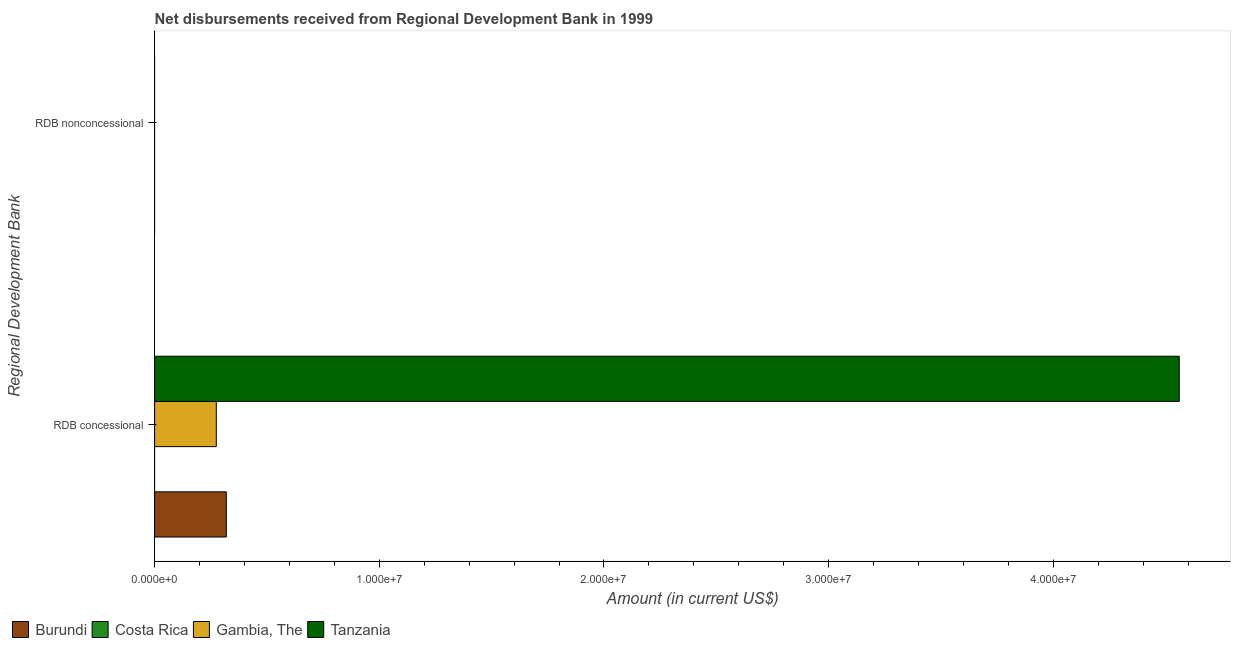How many different coloured bars are there?
Offer a terse response. 3. What is the label of the 2nd group of bars from the top?
Give a very brief answer. RDB concessional. What is the net concessional disbursements from rdb in Gambia, The?
Give a very brief answer. 2.75e+06. Across all countries, what is the maximum net concessional disbursements from rdb?
Give a very brief answer. 4.56e+07. Across all countries, what is the minimum net concessional disbursements from rdb?
Your answer should be compact. 0. In which country was the net concessional disbursements from rdb maximum?
Your answer should be compact. Tanzania. What is the total net non concessional disbursements from rdb in the graph?
Ensure brevity in your answer.  0. What is the difference between the net concessional disbursements from rdb in Gambia, The and that in Burundi?
Provide a succinct answer. -4.45e+05. What is the difference between the net concessional disbursements from rdb in Burundi and the net non concessional disbursements from rdb in Gambia, The?
Ensure brevity in your answer.  3.19e+06. What is the ratio of the net concessional disbursements from rdb in Tanzania to that in Burundi?
Give a very brief answer. 14.29. How many bars are there?
Provide a short and direct response. 3. How many countries are there in the graph?
Give a very brief answer. 4. What is the title of the graph?
Make the answer very short. Net disbursements received from Regional Development Bank in 1999. Does "Egypt, Arab Rep." appear as one of the legend labels in the graph?
Your answer should be very brief. No. What is the label or title of the Y-axis?
Keep it short and to the point. Regional Development Bank. What is the Amount (in current US$) in Burundi in RDB concessional?
Your answer should be very brief. 3.19e+06. What is the Amount (in current US$) in Costa Rica in RDB concessional?
Your response must be concise. 0. What is the Amount (in current US$) of Gambia, The in RDB concessional?
Provide a short and direct response. 2.75e+06. What is the Amount (in current US$) of Tanzania in RDB concessional?
Provide a short and direct response. 4.56e+07. What is the Amount (in current US$) of Tanzania in RDB nonconcessional?
Your response must be concise. 0. Across all Regional Development Bank, what is the maximum Amount (in current US$) of Burundi?
Give a very brief answer. 3.19e+06. Across all Regional Development Bank, what is the maximum Amount (in current US$) of Gambia, The?
Make the answer very short. 2.75e+06. Across all Regional Development Bank, what is the maximum Amount (in current US$) in Tanzania?
Your answer should be very brief. 4.56e+07. Across all Regional Development Bank, what is the minimum Amount (in current US$) of Burundi?
Offer a terse response. 0. Across all Regional Development Bank, what is the minimum Amount (in current US$) of Gambia, The?
Your answer should be compact. 0. Across all Regional Development Bank, what is the minimum Amount (in current US$) in Tanzania?
Provide a succinct answer. 0. What is the total Amount (in current US$) in Burundi in the graph?
Give a very brief answer. 3.19e+06. What is the total Amount (in current US$) of Gambia, The in the graph?
Provide a succinct answer. 2.75e+06. What is the total Amount (in current US$) of Tanzania in the graph?
Give a very brief answer. 4.56e+07. What is the average Amount (in current US$) of Burundi per Regional Development Bank?
Keep it short and to the point. 1.60e+06. What is the average Amount (in current US$) in Gambia, The per Regional Development Bank?
Offer a very short reply. 1.37e+06. What is the average Amount (in current US$) of Tanzania per Regional Development Bank?
Offer a very short reply. 2.28e+07. What is the difference between the Amount (in current US$) in Burundi and Amount (in current US$) in Gambia, The in RDB concessional?
Give a very brief answer. 4.45e+05. What is the difference between the Amount (in current US$) of Burundi and Amount (in current US$) of Tanzania in RDB concessional?
Offer a terse response. -4.24e+07. What is the difference between the Amount (in current US$) in Gambia, The and Amount (in current US$) in Tanzania in RDB concessional?
Your answer should be compact. -4.29e+07. What is the difference between the highest and the lowest Amount (in current US$) in Burundi?
Provide a succinct answer. 3.19e+06. What is the difference between the highest and the lowest Amount (in current US$) in Gambia, The?
Ensure brevity in your answer.  2.75e+06. What is the difference between the highest and the lowest Amount (in current US$) of Tanzania?
Provide a short and direct response. 4.56e+07. 